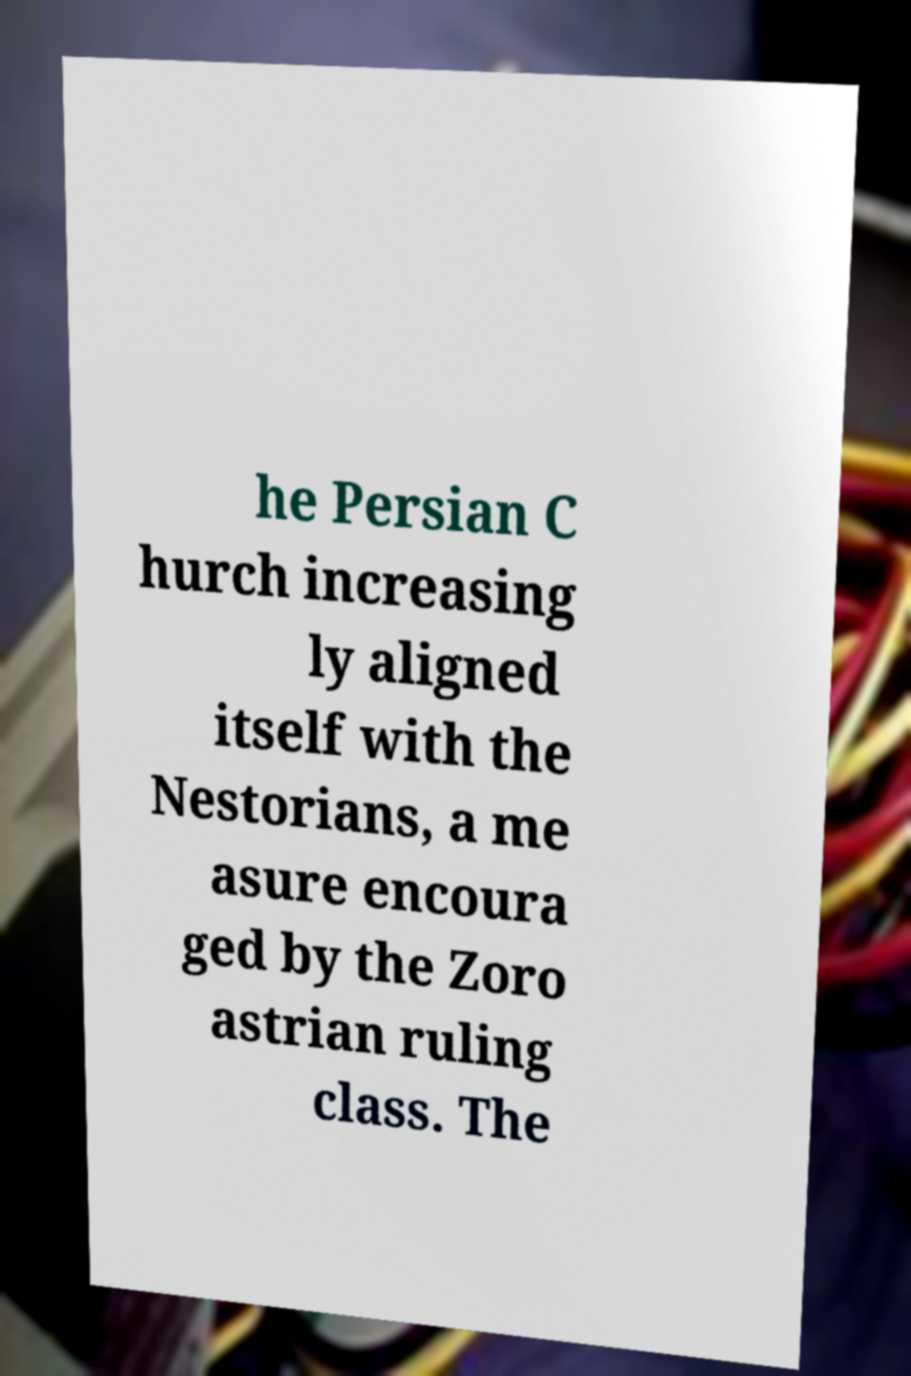What messages or text are displayed in this image? I need them in a readable, typed format. he Persian C hurch increasing ly aligned itself with the Nestorians, a me asure encoura ged by the Zoro astrian ruling class. The 